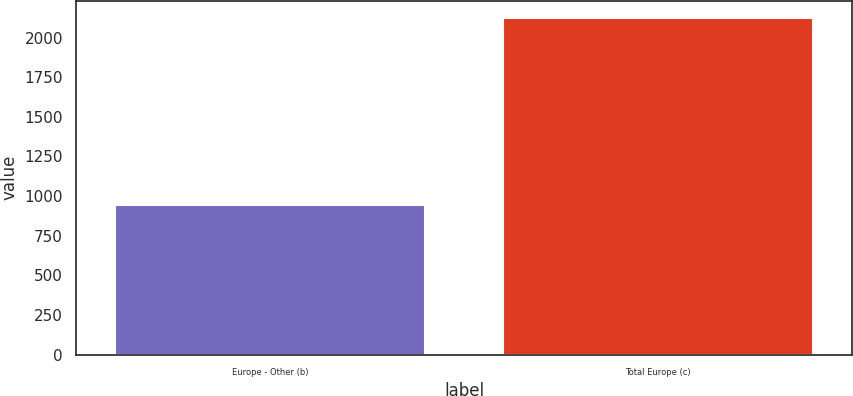Convert chart. <chart><loc_0><loc_0><loc_500><loc_500><bar_chart><fcel>Europe - Other (b)<fcel>Total Europe (c)<nl><fcel>944<fcel>2126<nl></chart> 